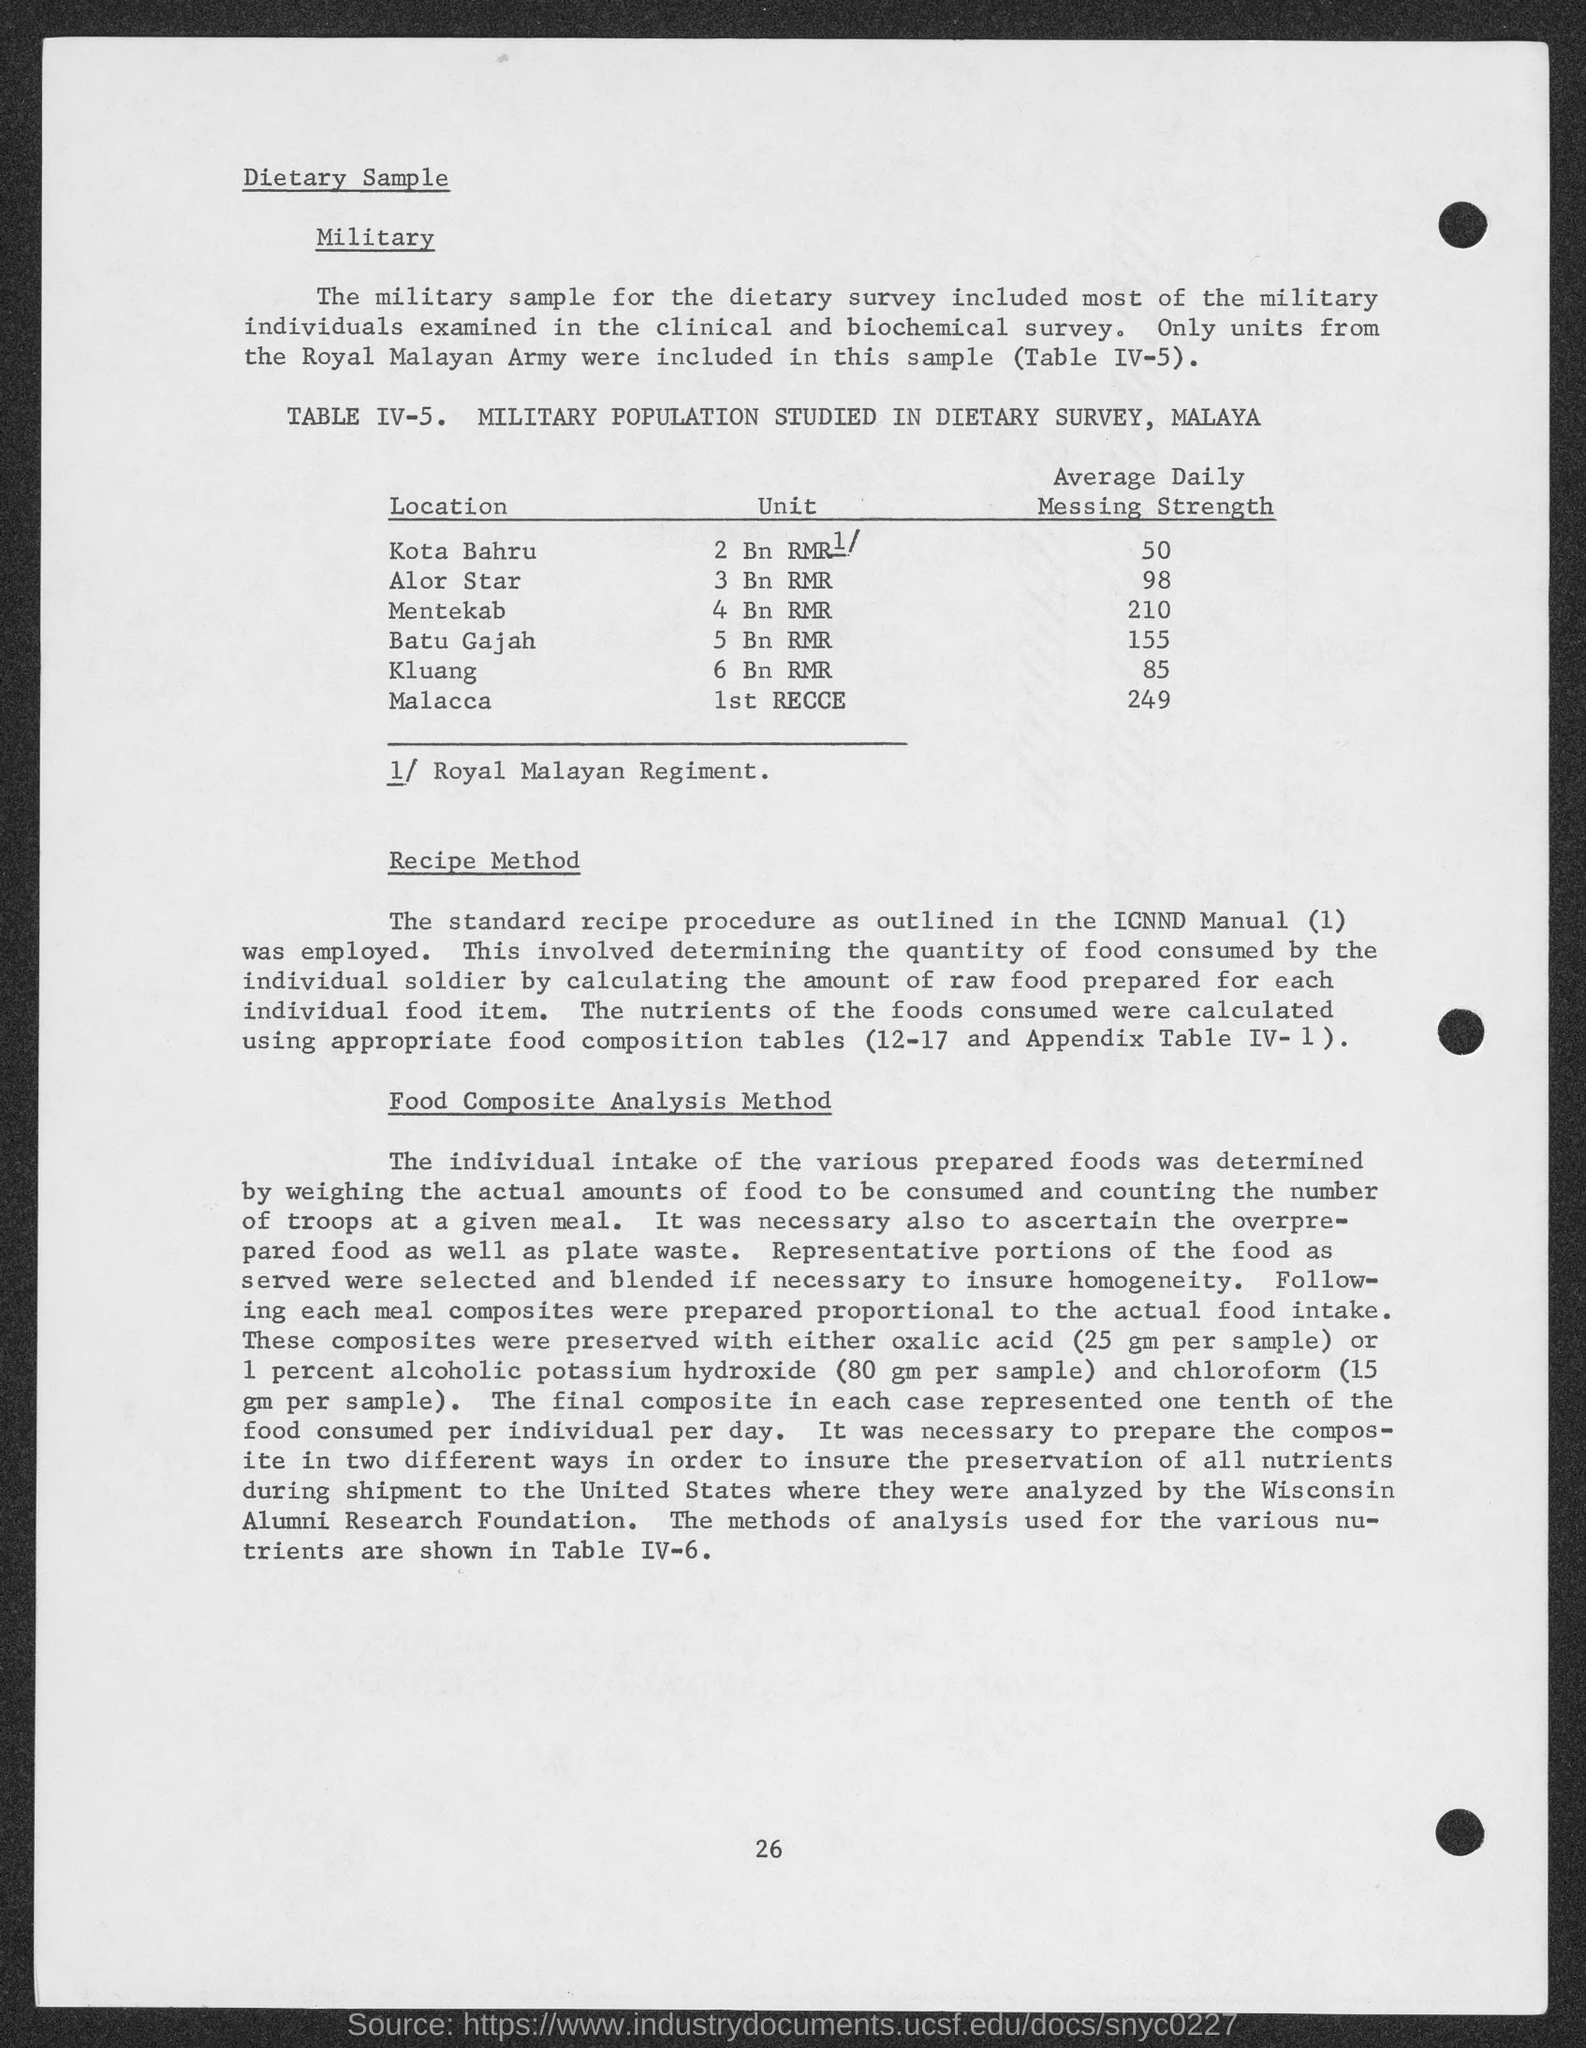What is the Average Daily Messing Strength for Kota Bahru?
Make the answer very short. 50. What is the Average Daily Messing Strength for Alor Star?
Provide a succinct answer. 98. What is the Average Daily Messing Strength for Mentekab?
Provide a short and direct response. 210. What is the Average Daily Messing Strength for Batu Gajah?
Make the answer very short. 155. What is the Average Daily Messing Strength for Kluang?
Provide a succinct answer. 85. What is the Average Daily Messing Strength for Malacca?
Your response must be concise. 249. What is the Unit for Alor Star?
Offer a very short reply. 3 Bn RMR. What is the Unit for Mentekab?
Give a very brief answer. 4 BN RMR. What is the Unit for Batu Gajah?
Your answer should be compact. 5 Bn RMR. What is the Unit for Kluang?
Your response must be concise. 6 BN RMR. What is the Unit for Malacca?
Provide a succinct answer. 1st RECCE. 